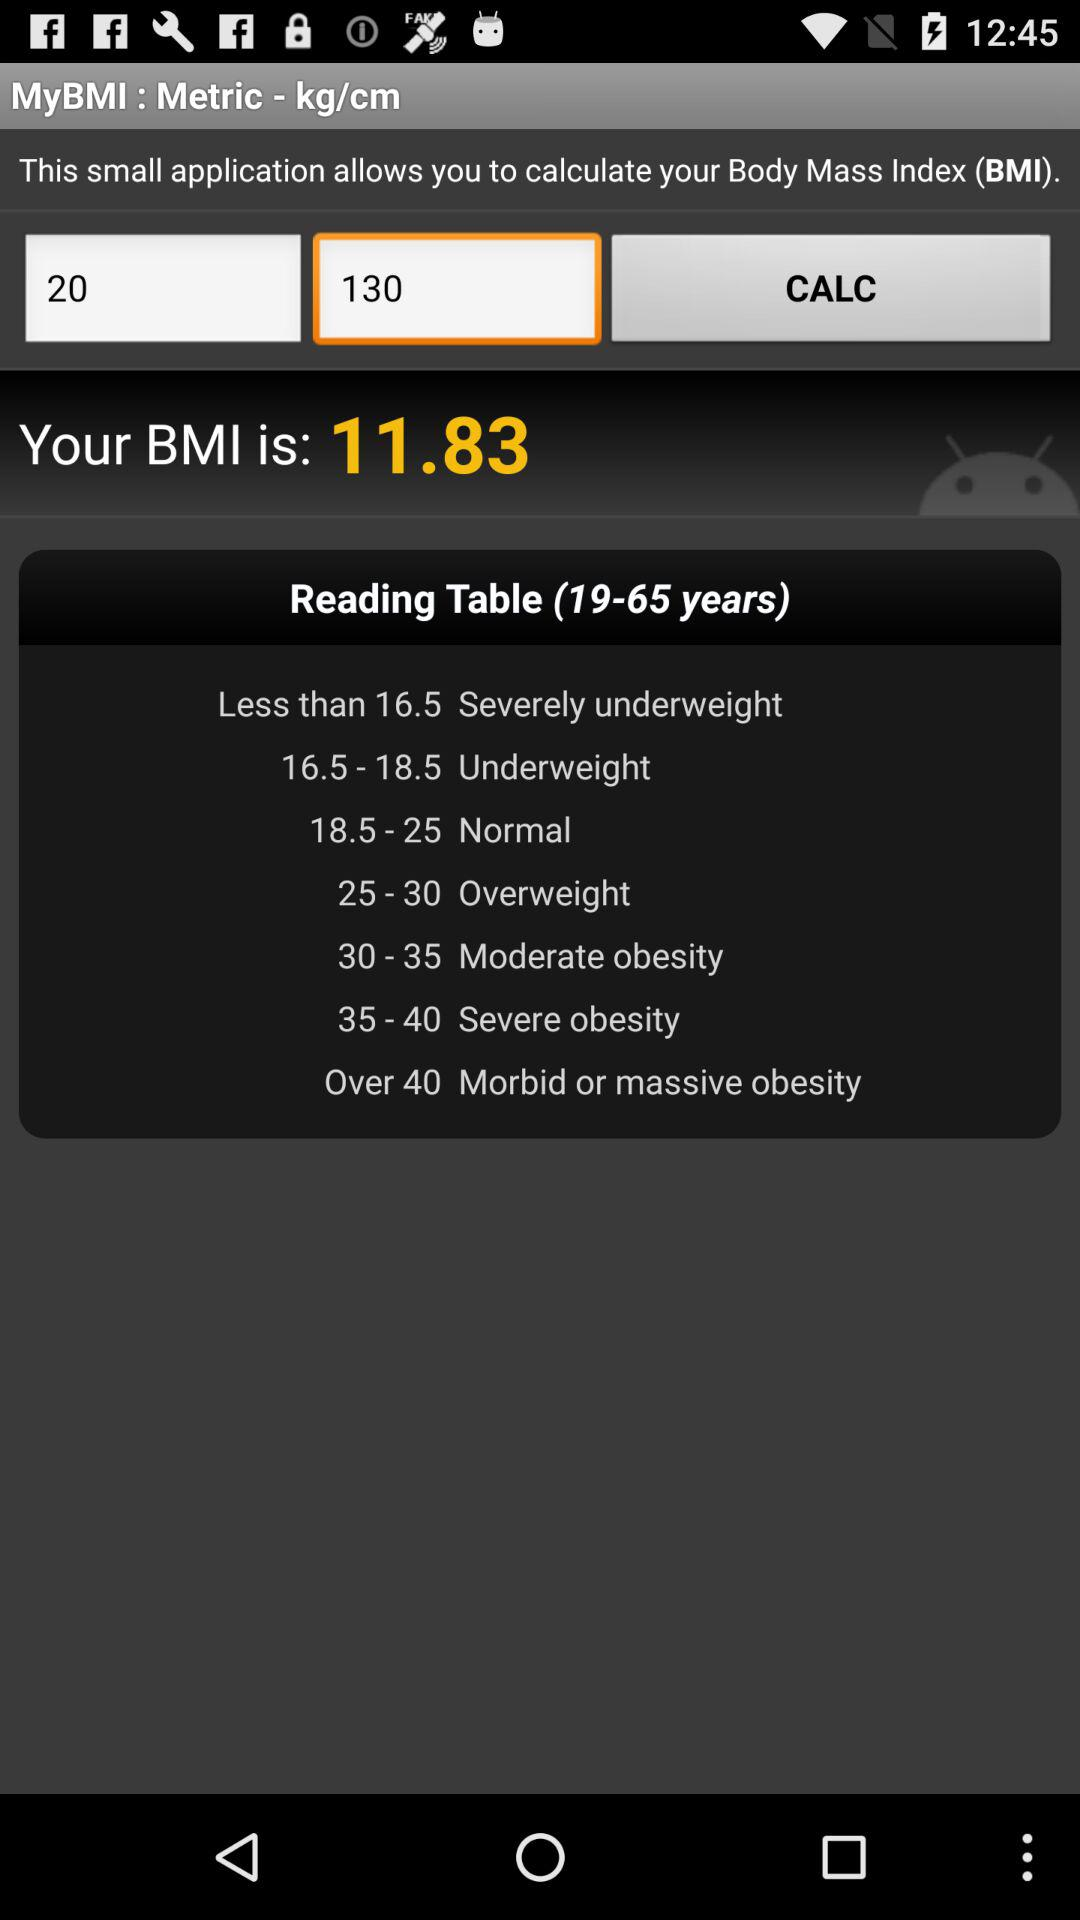What is the application name? The application name is "MyBMI". 